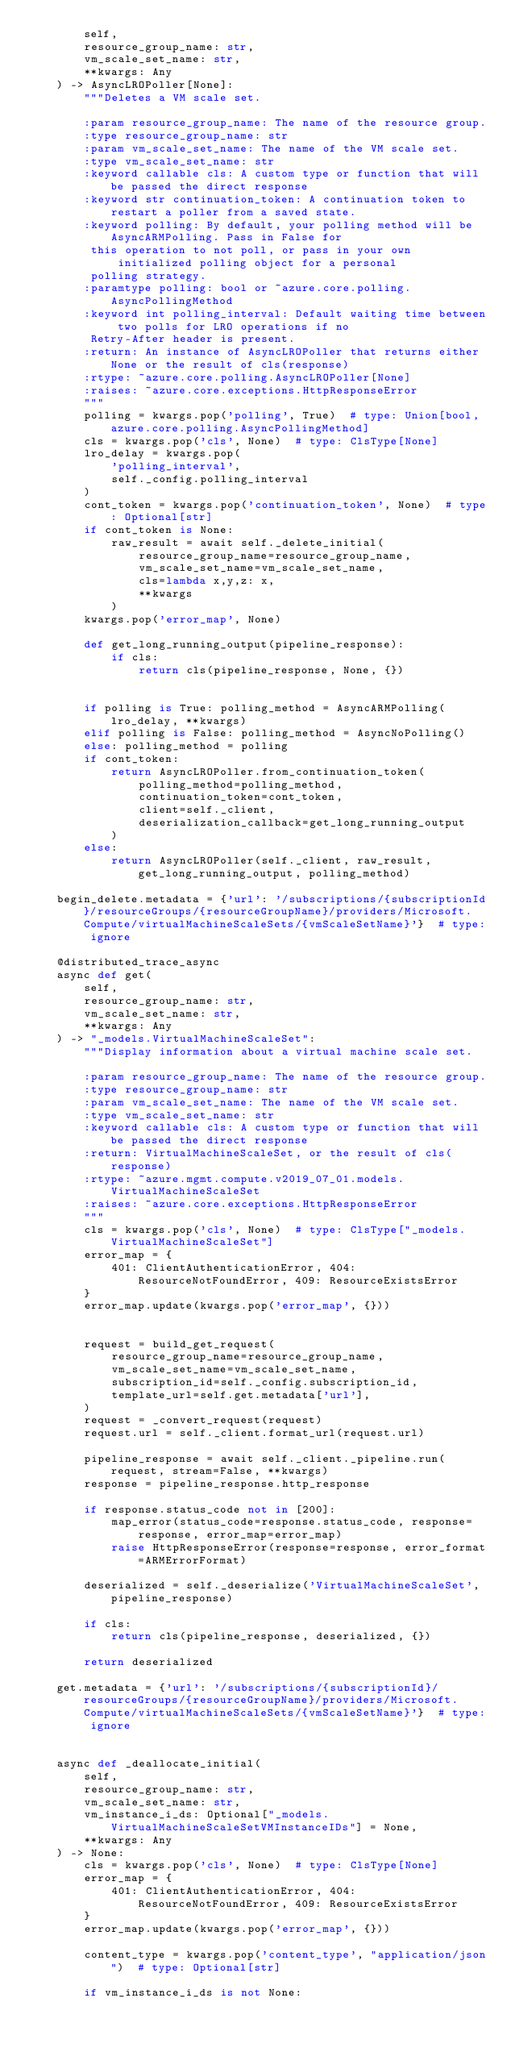<code> <loc_0><loc_0><loc_500><loc_500><_Python_>        self,
        resource_group_name: str,
        vm_scale_set_name: str,
        **kwargs: Any
    ) -> AsyncLROPoller[None]:
        """Deletes a VM scale set.

        :param resource_group_name: The name of the resource group.
        :type resource_group_name: str
        :param vm_scale_set_name: The name of the VM scale set.
        :type vm_scale_set_name: str
        :keyword callable cls: A custom type or function that will be passed the direct response
        :keyword str continuation_token: A continuation token to restart a poller from a saved state.
        :keyword polling: By default, your polling method will be AsyncARMPolling. Pass in False for
         this operation to not poll, or pass in your own initialized polling object for a personal
         polling strategy.
        :paramtype polling: bool or ~azure.core.polling.AsyncPollingMethod
        :keyword int polling_interval: Default waiting time between two polls for LRO operations if no
         Retry-After header is present.
        :return: An instance of AsyncLROPoller that returns either None or the result of cls(response)
        :rtype: ~azure.core.polling.AsyncLROPoller[None]
        :raises: ~azure.core.exceptions.HttpResponseError
        """
        polling = kwargs.pop('polling', True)  # type: Union[bool, azure.core.polling.AsyncPollingMethod]
        cls = kwargs.pop('cls', None)  # type: ClsType[None]
        lro_delay = kwargs.pop(
            'polling_interval',
            self._config.polling_interval
        )
        cont_token = kwargs.pop('continuation_token', None)  # type: Optional[str]
        if cont_token is None:
            raw_result = await self._delete_initial(
                resource_group_name=resource_group_name,
                vm_scale_set_name=vm_scale_set_name,
                cls=lambda x,y,z: x,
                **kwargs
            )
        kwargs.pop('error_map', None)

        def get_long_running_output(pipeline_response):
            if cls:
                return cls(pipeline_response, None, {})


        if polling is True: polling_method = AsyncARMPolling(lro_delay, **kwargs)
        elif polling is False: polling_method = AsyncNoPolling()
        else: polling_method = polling
        if cont_token:
            return AsyncLROPoller.from_continuation_token(
                polling_method=polling_method,
                continuation_token=cont_token,
                client=self._client,
                deserialization_callback=get_long_running_output
            )
        else:
            return AsyncLROPoller(self._client, raw_result, get_long_running_output, polling_method)

    begin_delete.metadata = {'url': '/subscriptions/{subscriptionId}/resourceGroups/{resourceGroupName}/providers/Microsoft.Compute/virtualMachineScaleSets/{vmScaleSetName}'}  # type: ignore

    @distributed_trace_async
    async def get(
        self,
        resource_group_name: str,
        vm_scale_set_name: str,
        **kwargs: Any
    ) -> "_models.VirtualMachineScaleSet":
        """Display information about a virtual machine scale set.

        :param resource_group_name: The name of the resource group.
        :type resource_group_name: str
        :param vm_scale_set_name: The name of the VM scale set.
        :type vm_scale_set_name: str
        :keyword callable cls: A custom type or function that will be passed the direct response
        :return: VirtualMachineScaleSet, or the result of cls(response)
        :rtype: ~azure.mgmt.compute.v2019_07_01.models.VirtualMachineScaleSet
        :raises: ~azure.core.exceptions.HttpResponseError
        """
        cls = kwargs.pop('cls', None)  # type: ClsType["_models.VirtualMachineScaleSet"]
        error_map = {
            401: ClientAuthenticationError, 404: ResourceNotFoundError, 409: ResourceExistsError
        }
        error_map.update(kwargs.pop('error_map', {}))

        
        request = build_get_request(
            resource_group_name=resource_group_name,
            vm_scale_set_name=vm_scale_set_name,
            subscription_id=self._config.subscription_id,
            template_url=self.get.metadata['url'],
        )
        request = _convert_request(request)
        request.url = self._client.format_url(request.url)

        pipeline_response = await self._client._pipeline.run(request, stream=False, **kwargs)
        response = pipeline_response.http_response

        if response.status_code not in [200]:
            map_error(status_code=response.status_code, response=response, error_map=error_map)
            raise HttpResponseError(response=response, error_format=ARMErrorFormat)

        deserialized = self._deserialize('VirtualMachineScaleSet', pipeline_response)

        if cls:
            return cls(pipeline_response, deserialized, {})

        return deserialized

    get.metadata = {'url': '/subscriptions/{subscriptionId}/resourceGroups/{resourceGroupName}/providers/Microsoft.Compute/virtualMachineScaleSets/{vmScaleSetName}'}  # type: ignore


    async def _deallocate_initial(
        self,
        resource_group_name: str,
        vm_scale_set_name: str,
        vm_instance_i_ds: Optional["_models.VirtualMachineScaleSetVMInstanceIDs"] = None,
        **kwargs: Any
    ) -> None:
        cls = kwargs.pop('cls', None)  # type: ClsType[None]
        error_map = {
            401: ClientAuthenticationError, 404: ResourceNotFoundError, 409: ResourceExistsError
        }
        error_map.update(kwargs.pop('error_map', {}))

        content_type = kwargs.pop('content_type', "application/json")  # type: Optional[str]

        if vm_instance_i_ds is not None:</code> 